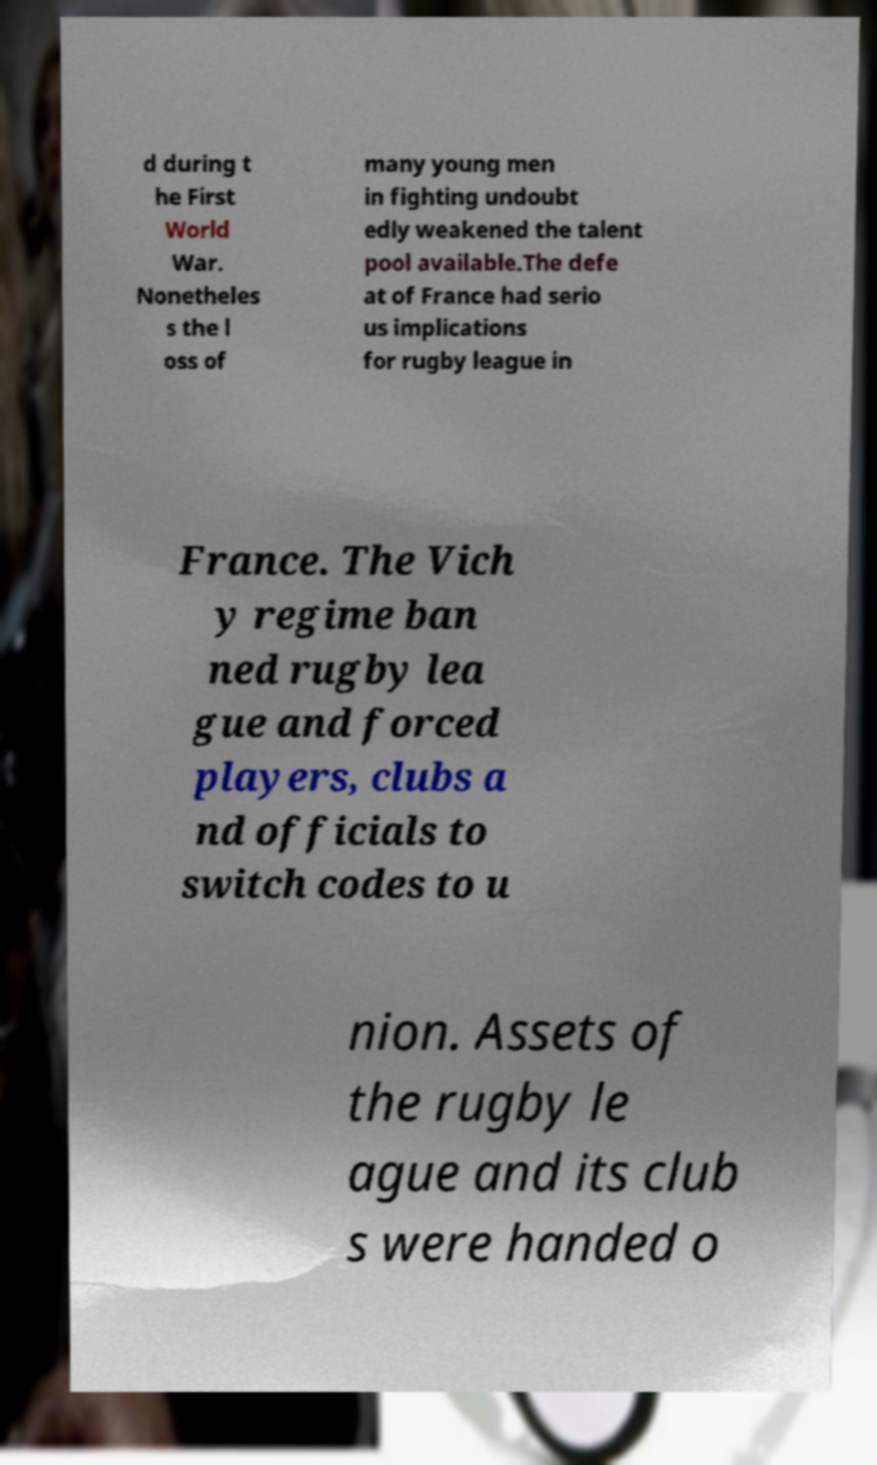Can you read and provide the text displayed in the image?This photo seems to have some interesting text. Can you extract and type it out for me? d during t he First World War. Nonetheles s the l oss of many young men in fighting undoubt edly weakened the talent pool available.The defe at of France had serio us implications for rugby league in France. The Vich y regime ban ned rugby lea gue and forced players, clubs a nd officials to switch codes to u nion. Assets of the rugby le ague and its club s were handed o 